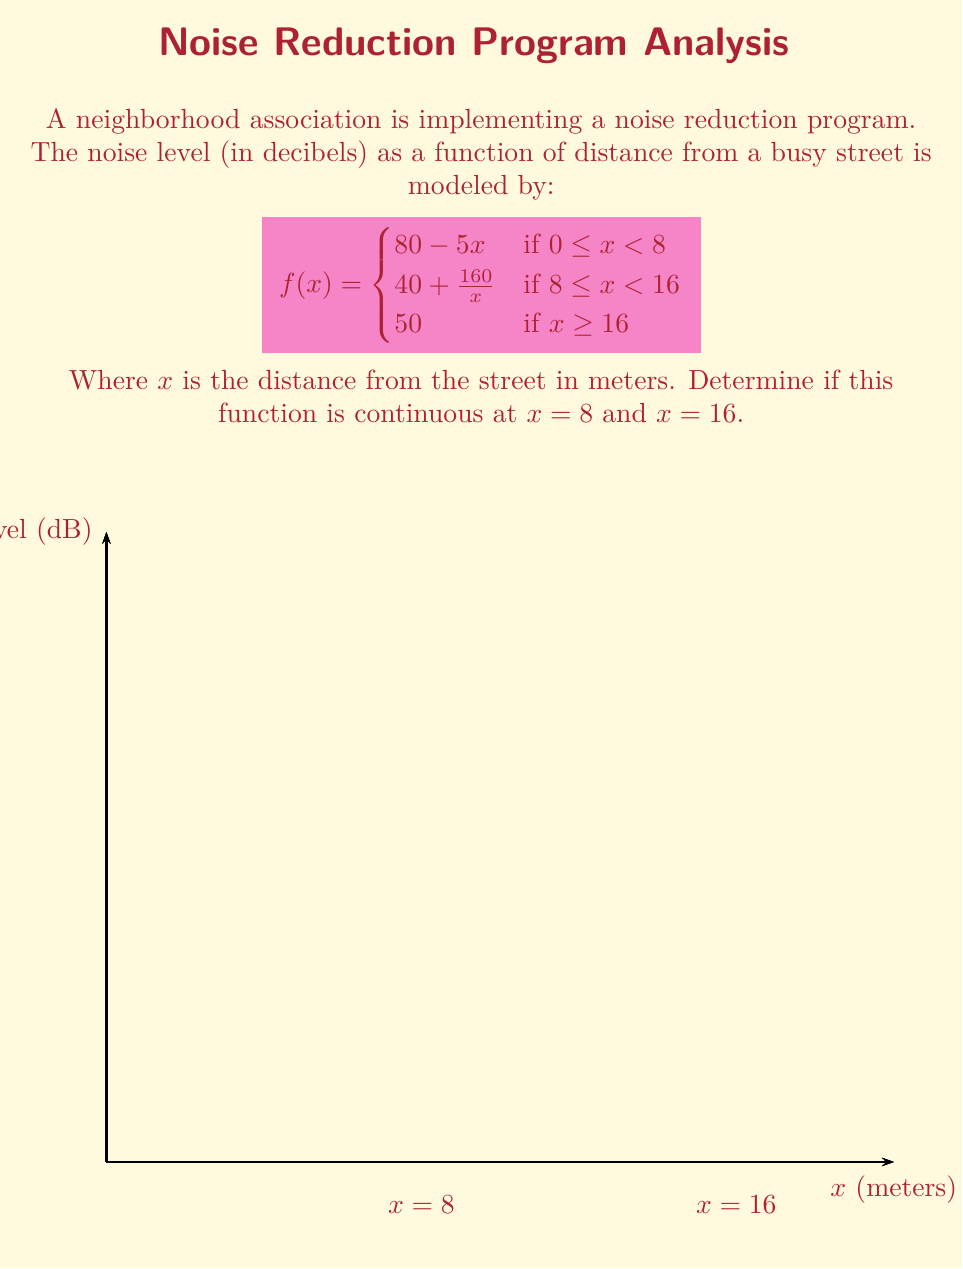Give your solution to this math problem. To determine if the function is continuous at $x = 8$ and $x = 16$, we need to check three conditions at each point:
1. The function is defined at the point
2. The limit of the function as we approach the point from both sides exists
3. The limit equals the function value at that point

For $x = 8$:
1. $f(8)$ is defined: $f(8) = 40 + \frac{160}{8} = 60$
2. Left limit: $\lim_{x \to 8^-} f(x) = \lim_{x \to 8^-} (80 - 5x) = 80 - 5(8) = 40$
   Right limit: $\lim_{x \to 8^+} f(x) = \lim_{x \to 8^+} (40 + \frac{160}{x}) = 40 + \frac{160}{8} = 60$
3. The left limit ≠ right limit ≠ $f(8)$

Therefore, $f(x)$ is not continuous at $x = 8$.

For $x = 16$:
1. $f(16)$ is defined: $f(16) = 50$
2. Left limit: $\lim_{x \to 16^-} f(x) = \lim_{x \to 16^-} (40 + \frac{160}{x}) = 40 + \frac{160}{16} = 50$
   Right limit: $\lim_{x \to 16^+} f(x) = 50$
3. The left limit = right limit = $f(16) = 50$

Therefore, $f(x)$ is continuous at $x = 16$.
Answer: The function is discontinuous at $x = 8$ but continuous at $x = 16$. 